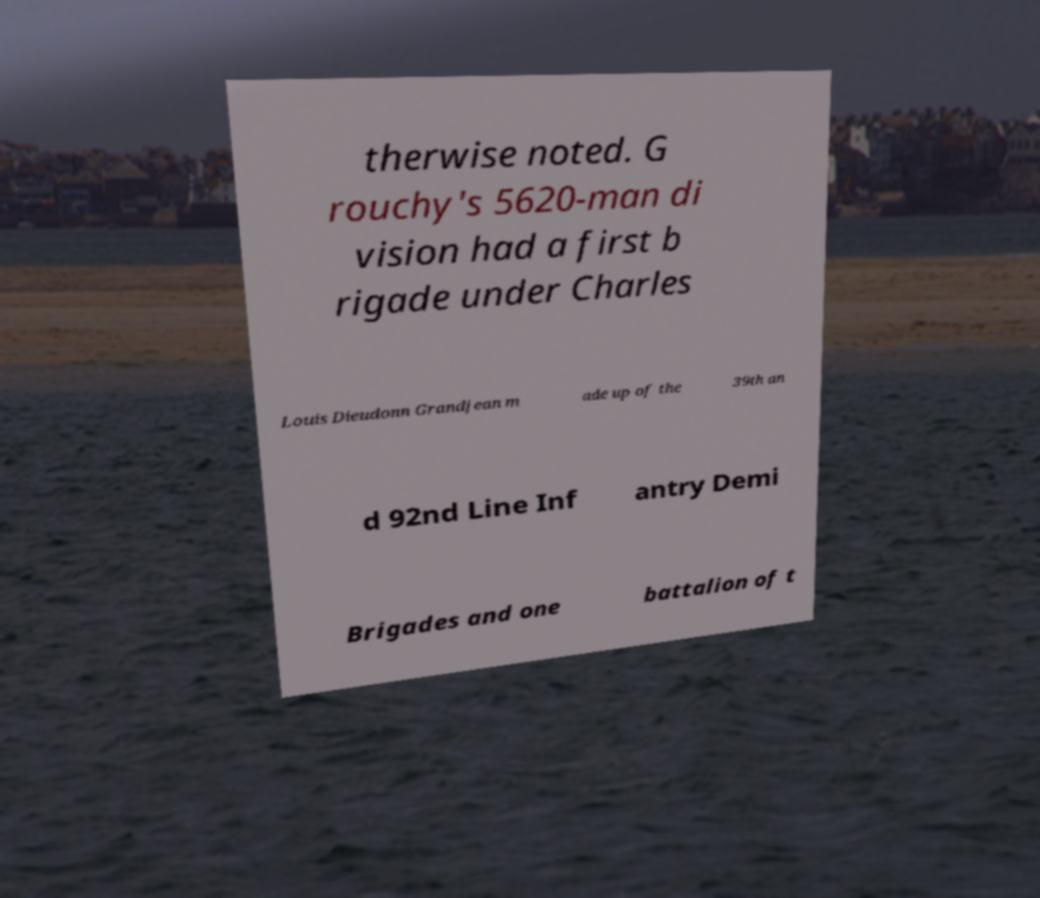Can you accurately transcribe the text from the provided image for me? therwise noted. G rouchy's 5620-man di vision had a first b rigade under Charles Louis Dieudonn Grandjean m ade up of the 39th an d 92nd Line Inf antry Demi Brigades and one battalion of t 